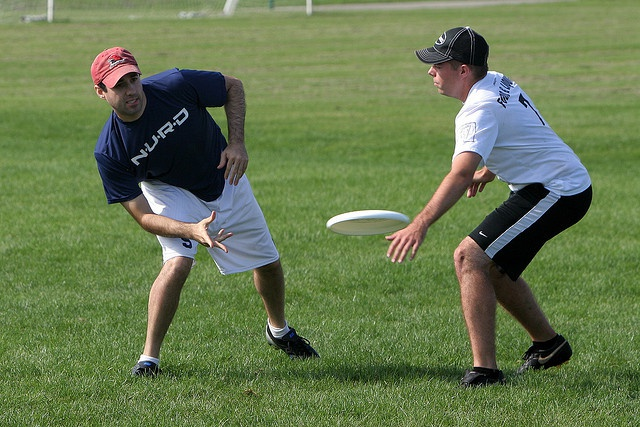Describe the objects in this image and their specific colors. I can see people in gray and black tones, people in gray, black, and darkgray tones, and frisbee in gray, white, and olive tones in this image. 